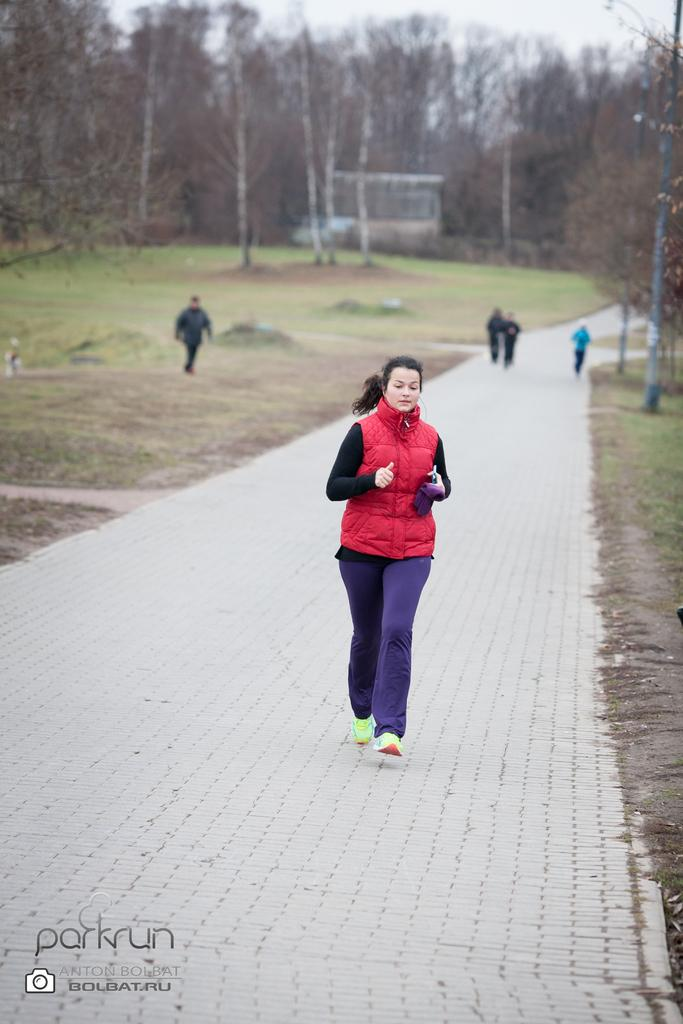Who is the main subject in the image? There is a woman in the image. What is the woman doing in the image? The woman is running. What is the woman wearing in the image? The woman is wearing a red jacket. What can be seen at the bottom of the image? There is a road at the bottom of the image. What type of vegetation is present on the sides of the image? There are trees to the left and right of the image. How many ducks are supporting the woman as she runs in the image? There are no ducks present in the image, and they are not supporting the woman as she runs. What type of toad can be seen interacting with the woman in the image? There is no toad present in the image, and no interaction with the woman is depicted. 